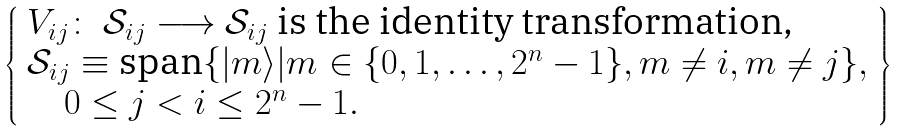Convert formula to latex. <formula><loc_0><loc_0><loc_500><loc_500>\left \{ \begin{array} { l } V _ { i j } \colon \ \mathcal { S } _ { i j } \longrightarrow \mathcal { S } _ { i j } \text { is the identity transformation,} \\ \mathcal { S } _ { i j } \equiv \text {span} \{ | m \rangle | m \in \{ 0 , 1 , \dots , 2 ^ { n } - 1 \} , m \ne i , m \ne j \} , \\ \quad 0 \leq j < i \leq 2 ^ { n } - 1 . \end{array} \right \}</formula> 